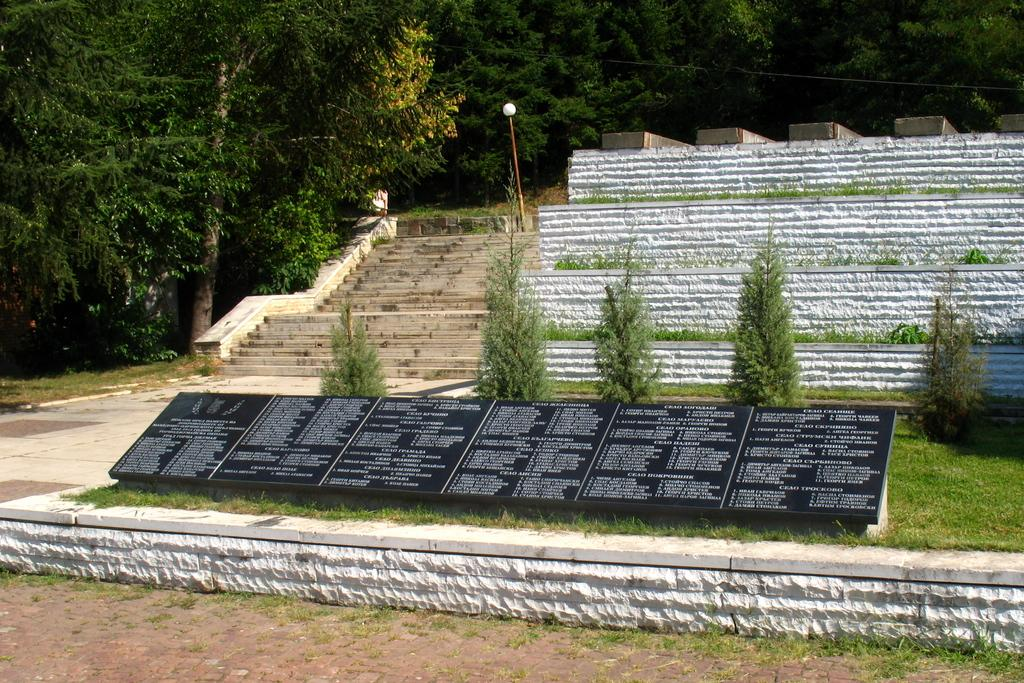What type of surface can be seen in the image? The ground with grass is visible in the image. What is written or displayed on an object in the image? There is text on an object in the image. Are there any architectural features in the image? Yes, there are stairs and a wall in the image. What other structures can be seen in the image? There is a pole in the image. What type of illumination is present in the image? There is a light in the image. What type of vegetation is visible in the image? There are trees in the image. Are there any wires or cables visible in the image? Yes, there is a wire in the image. How much sugar is in the drawer in the image? There is no drawer or sugar present in the image. 